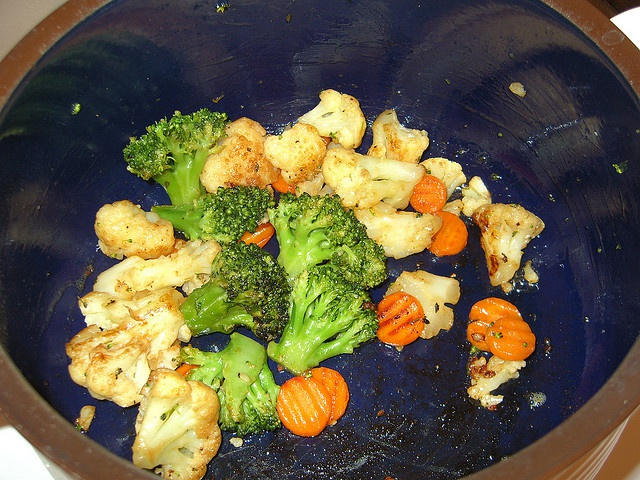Describe the objects in this image and their specific colors. I can see bowl in black, navy, olive, and khaki tones, broccoli in gray, darkgreen, olive, and black tones, broccoli in gray, lightgreen, olive, and khaki tones, carrot in gray, orange, red, and gold tones, and carrot in gray, red, orange, and black tones in this image. 